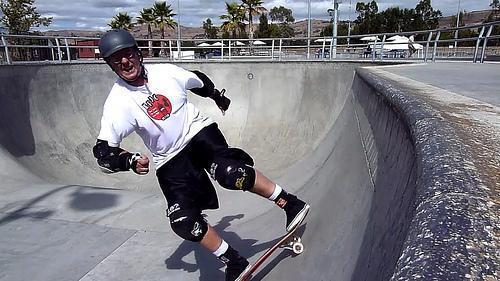How many skateboarders are pictured?
Give a very brief answer. 1. 